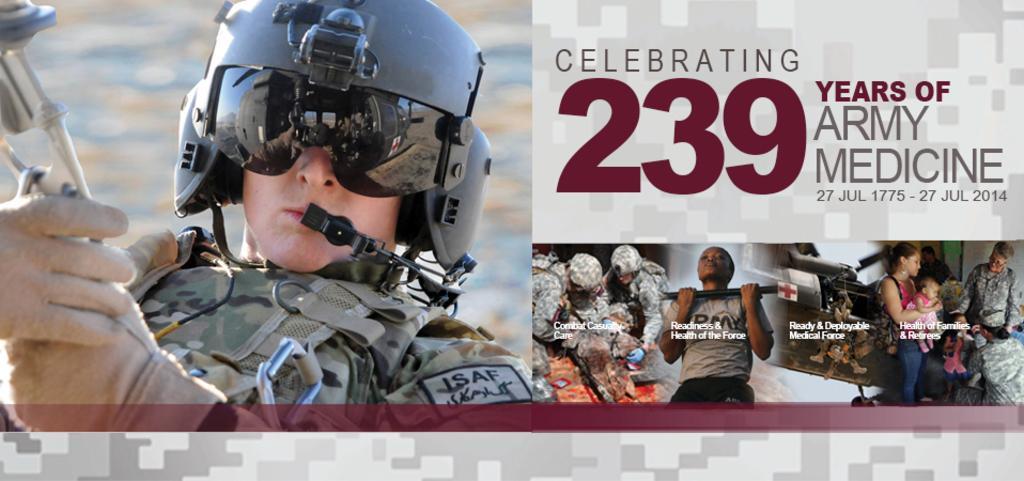In one or two sentences, can you explain what this image depicts? In the picture I can see people among them the person on the left side is wearing a uniform, a helmet and some other objects. On the right side of the image I can see kids, people and some text written on the image. 